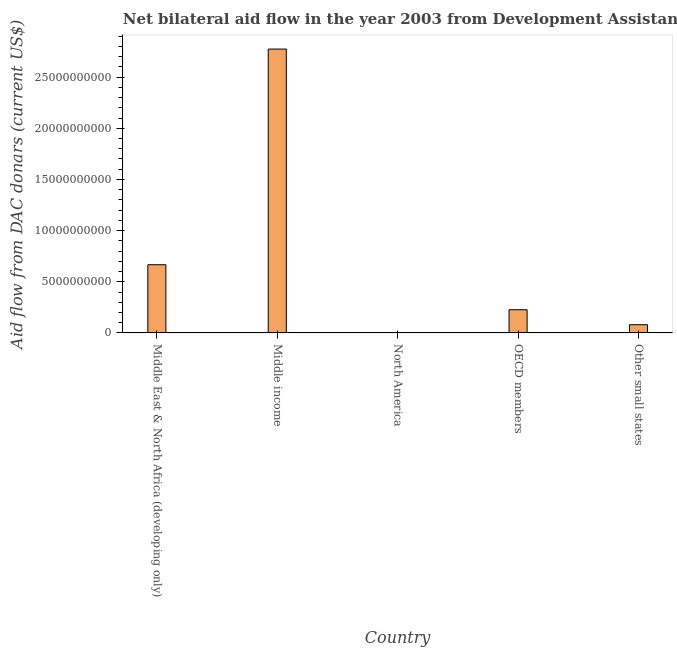Does the graph contain any zero values?
Make the answer very short. No. Does the graph contain grids?
Ensure brevity in your answer.  No. What is the title of the graph?
Your response must be concise. Net bilateral aid flow in the year 2003 from Development Assistance Committee. What is the label or title of the Y-axis?
Keep it short and to the point. Aid flow from DAC donars (current US$). What is the net bilateral aid flows from dac donors in Middle East & North Africa (developing only)?
Offer a very short reply. 6.67e+09. Across all countries, what is the maximum net bilateral aid flows from dac donors?
Your answer should be compact. 2.77e+1. In which country was the net bilateral aid flows from dac donors minimum?
Offer a terse response. North America. What is the sum of the net bilateral aid flows from dac donors?
Give a very brief answer. 3.75e+1. What is the difference between the net bilateral aid flows from dac donors in Middle income and Other small states?
Keep it short and to the point. 2.69e+1. What is the average net bilateral aid flows from dac donors per country?
Your response must be concise. 7.50e+09. What is the median net bilateral aid flows from dac donors?
Your answer should be very brief. 2.27e+09. Is the difference between the net bilateral aid flows from dac donors in North America and OECD members greater than the difference between any two countries?
Provide a short and direct response. No. What is the difference between the highest and the second highest net bilateral aid flows from dac donors?
Keep it short and to the point. 2.11e+1. What is the difference between the highest and the lowest net bilateral aid flows from dac donors?
Ensure brevity in your answer.  2.77e+1. How many bars are there?
Offer a very short reply. 5. How many countries are there in the graph?
Your answer should be very brief. 5. Are the values on the major ticks of Y-axis written in scientific E-notation?
Your answer should be very brief. No. What is the Aid flow from DAC donars (current US$) of Middle East & North Africa (developing only)?
Offer a very short reply. 6.67e+09. What is the Aid flow from DAC donars (current US$) of Middle income?
Give a very brief answer. 2.77e+1. What is the Aid flow from DAC donars (current US$) of OECD members?
Provide a short and direct response. 2.27e+09. What is the Aid flow from DAC donars (current US$) in Other small states?
Your answer should be very brief. 8.02e+08. What is the difference between the Aid flow from DAC donars (current US$) in Middle East & North Africa (developing only) and Middle income?
Your answer should be very brief. -2.11e+1. What is the difference between the Aid flow from DAC donars (current US$) in Middle East & North Africa (developing only) and North America?
Offer a very short reply. 6.67e+09. What is the difference between the Aid flow from DAC donars (current US$) in Middle East & North Africa (developing only) and OECD members?
Provide a short and direct response. 4.40e+09. What is the difference between the Aid flow from DAC donars (current US$) in Middle East & North Africa (developing only) and Other small states?
Provide a succinct answer. 5.86e+09. What is the difference between the Aid flow from DAC donars (current US$) in Middle income and North America?
Your answer should be very brief. 2.77e+1. What is the difference between the Aid flow from DAC donars (current US$) in Middle income and OECD members?
Your answer should be very brief. 2.55e+1. What is the difference between the Aid flow from DAC donars (current US$) in Middle income and Other small states?
Ensure brevity in your answer.  2.69e+1. What is the difference between the Aid flow from DAC donars (current US$) in North America and OECD members?
Offer a terse response. -2.27e+09. What is the difference between the Aid flow from DAC donars (current US$) in North America and Other small states?
Offer a very short reply. -8.02e+08. What is the difference between the Aid flow from DAC donars (current US$) in OECD members and Other small states?
Give a very brief answer. 1.47e+09. What is the ratio of the Aid flow from DAC donars (current US$) in Middle East & North Africa (developing only) to that in Middle income?
Offer a terse response. 0.24. What is the ratio of the Aid flow from DAC donars (current US$) in Middle East & North Africa (developing only) to that in North America?
Provide a short and direct response. 2.22e+05. What is the ratio of the Aid flow from DAC donars (current US$) in Middle East & North Africa (developing only) to that in OECD members?
Make the answer very short. 2.94. What is the ratio of the Aid flow from DAC donars (current US$) in Middle East & North Africa (developing only) to that in Other small states?
Offer a terse response. 8.31. What is the ratio of the Aid flow from DAC donars (current US$) in Middle income to that in North America?
Provide a succinct answer. 9.25e+05. What is the ratio of the Aid flow from DAC donars (current US$) in Middle income to that in OECD members?
Give a very brief answer. 12.23. What is the ratio of the Aid flow from DAC donars (current US$) in Middle income to that in Other small states?
Offer a very short reply. 34.58. What is the ratio of the Aid flow from DAC donars (current US$) in North America to that in OECD members?
Your answer should be very brief. 0. What is the ratio of the Aid flow from DAC donars (current US$) in North America to that in Other small states?
Make the answer very short. 0. What is the ratio of the Aid flow from DAC donars (current US$) in OECD members to that in Other small states?
Your answer should be very brief. 2.83. 